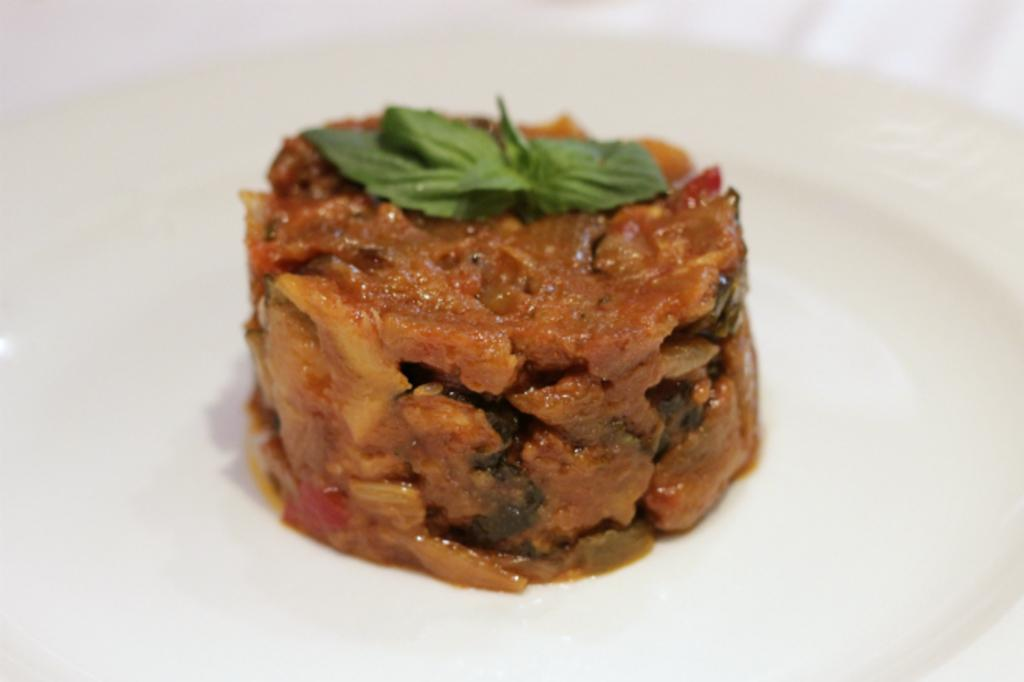What is on the platform in the image? There is food on a platform in the image. What color is the platform? The platform is white. What can be seen in the background of the image? The background of the image is white. What type of authority is depicted in the image? There is no authority figure present in the image; it features food on a white platform with a white background. 